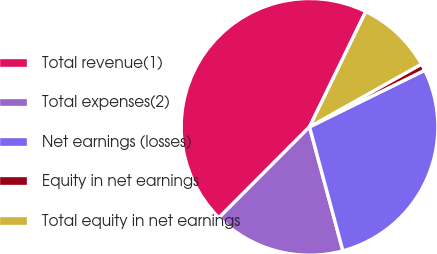<chart> <loc_0><loc_0><loc_500><loc_500><pie_chart><fcel>Total revenue(1)<fcel>Total expenses(2)<fcel>Net earnings (losses)<fcel>Equity in net earnings<fcel>Total equity in net earnings<nl><fcel>44.75%<fcel>16.66%<fcel>28.09%<fcel>0.86%<fcel>9.64%<nl></chart> 